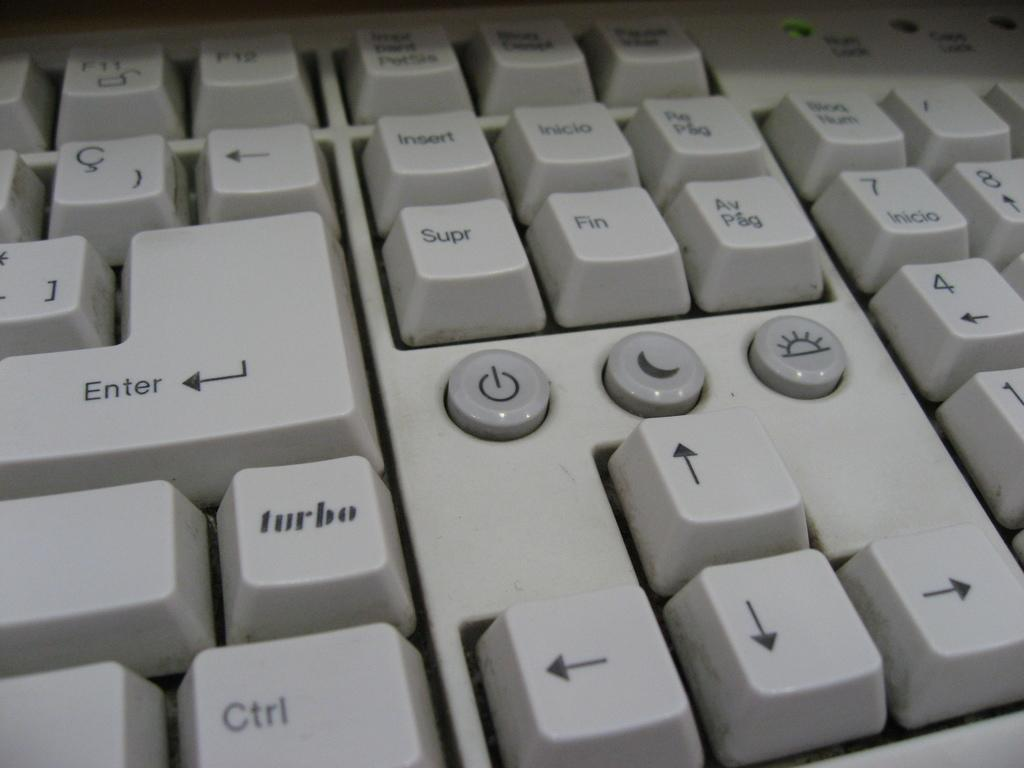<image>
Provide a brief description of the given image. The Turbo button is located directly beneath the Enter button on the keyboard 